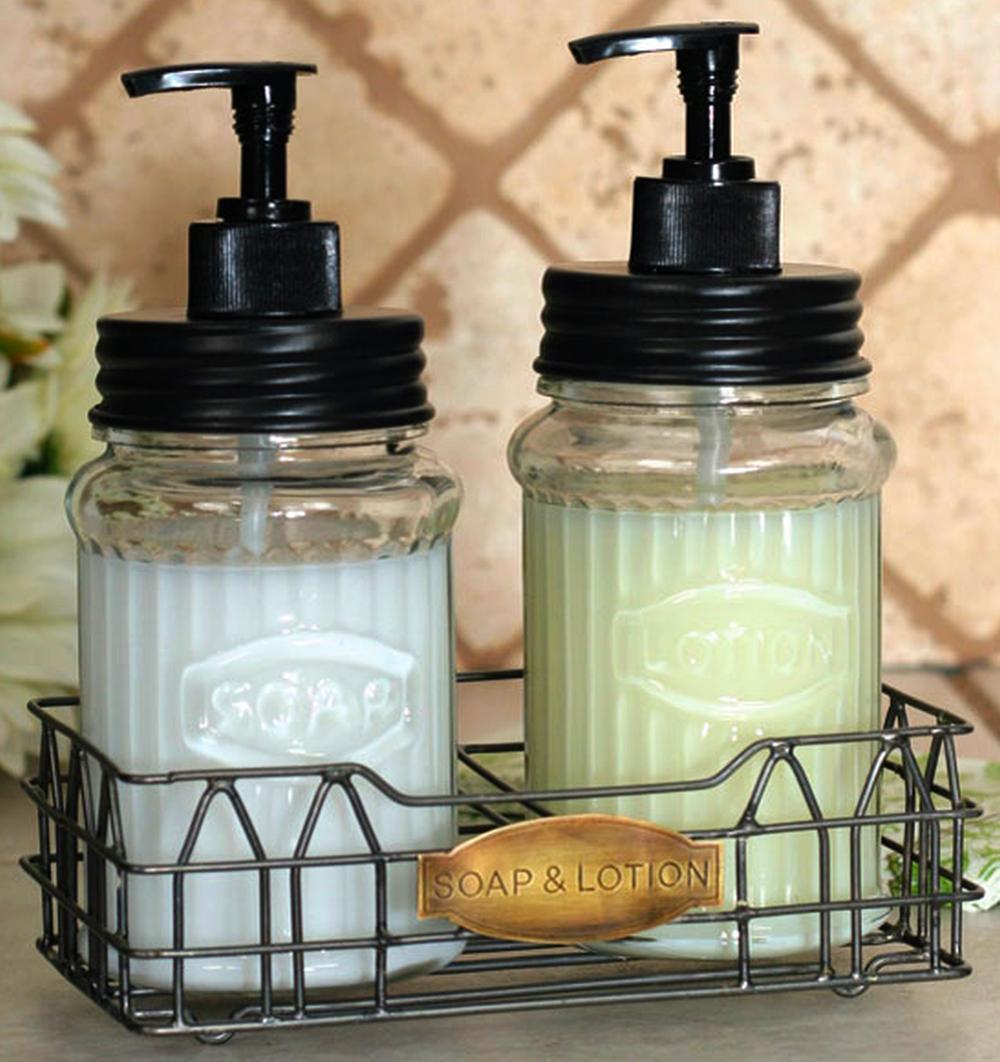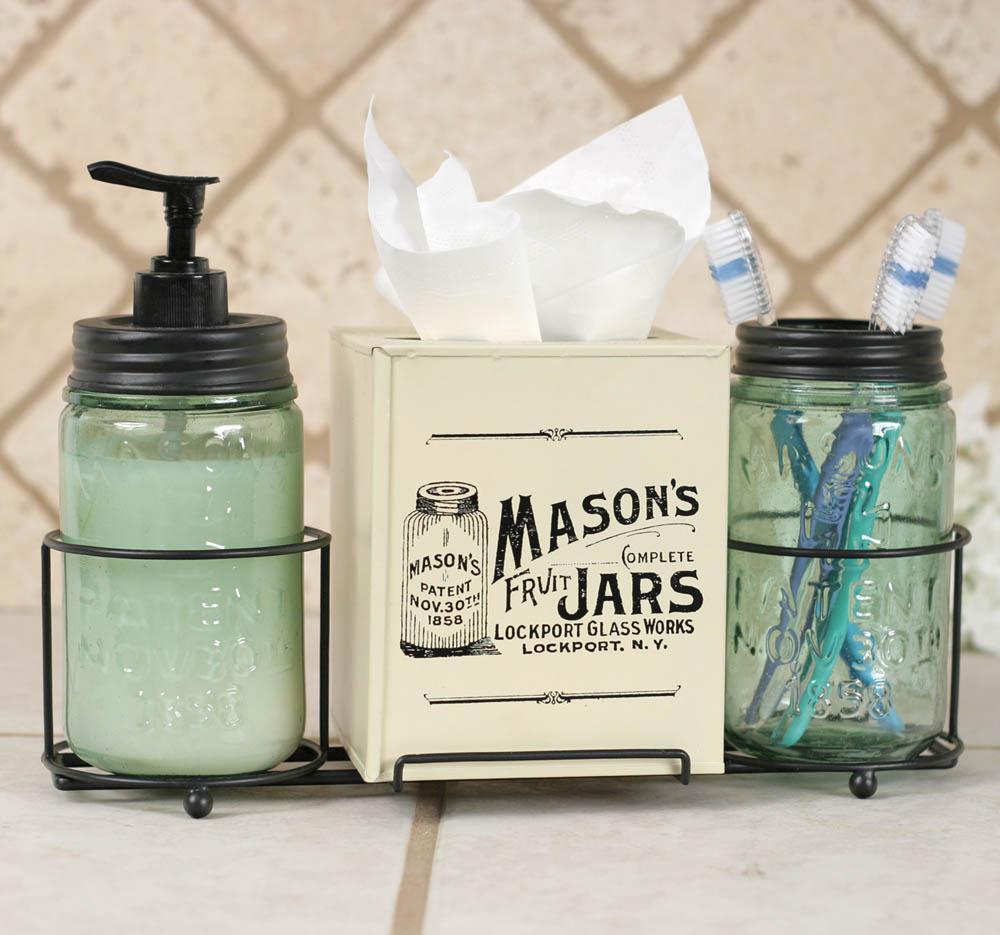The first image is the image on the left, the second image is the image on the right. Given the left and right images, does the statement "An image shows a pair of pump-top dispensers in a wire caddy with an oval medallion on the front, and the other image includes a jar of toothbrushes." hold true? Answer yes or no. Yes. The first image is the image on the left, the second image is the image on the right. Evaluate the accuracy of this statement regarding the images: "The left image contains exactly two glass jar dispensers.". Is it true? Answer yes or no. Yes. 